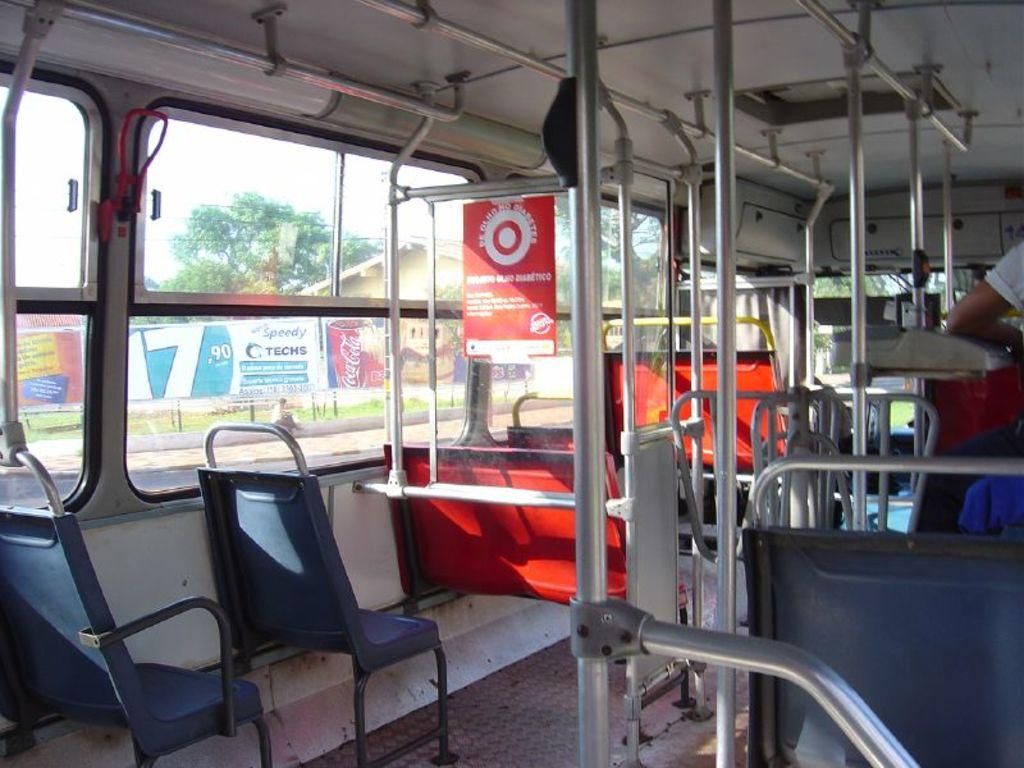What objects are present in the image that are not occupied? There are empty chairs in the image. What type of vertical structures can be seen in the image? There are poles in the image. What color is the poster inside the bus? The red poster is placed inside a bus. Can you describe the person's position in the image? There is a person standing in the right corner of the image. What type of chain is hanging from the poles in the image? There is no chain hanging from the poles in the image. What is the name of the person standing in the right corner of the image? The provided facts do not mention the name of the person standing in the image. Are there any mittens visible in the image? There are no mittens present in the image. 